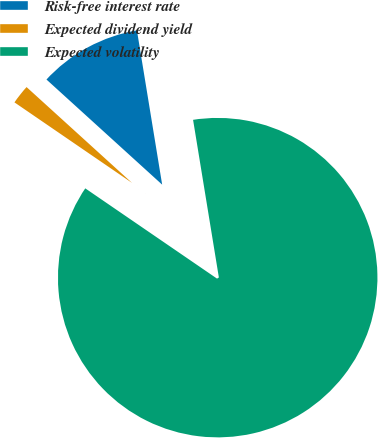Convert chart to OTSL. <chart><loc_0><loc_0><loc_500><loc_500><pie_chart><fcel>Risk-free interest rate<fcel>Expected dividend yield<fcel>Expected volatility<nl><fcel>10.68%<fcel>2.18%<fcel>87.14%<nl></chart> 